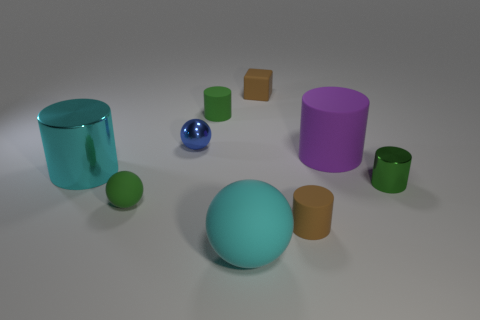Is the number of tiny objects less than the number of big brown rubber blocks?
Your answer should be compact. No. Is there any other thing that is the same size as the cyan matte ball?
Make the answer very short. Yes. There is a small green thing that is the same shape as the cyan matte thing; what material is it?
Your answer should be very brief. Rubber. Are there more big purple objects than green rubber objects?
Offer a very short reply. No. How many other things are there of the same color as the small rubber ball?
Your response must be concise. 2. Is the cyan sphere made of the same material as the tiny ball that is left of the blue ball?
Give a very brief answer. Yes. There is a green cylinder in front of the cyan shiny cylinder on the left side of the large purple rubber thing; what number of small blue objects are left of it?
Make the answer very short. 1. Are there fewer big purple cylinders to the right of the cyan matte ball than matte blocks that are on the left side of the rubber block?
Provide a succinct answer. No. What number of other things are there of the same material as the cyan sphere
Your answer should be very brief. 5. There is a purple thing that is the same size as the cyan rubber ball; what material is it?
Your response must be concise. Rubber. 